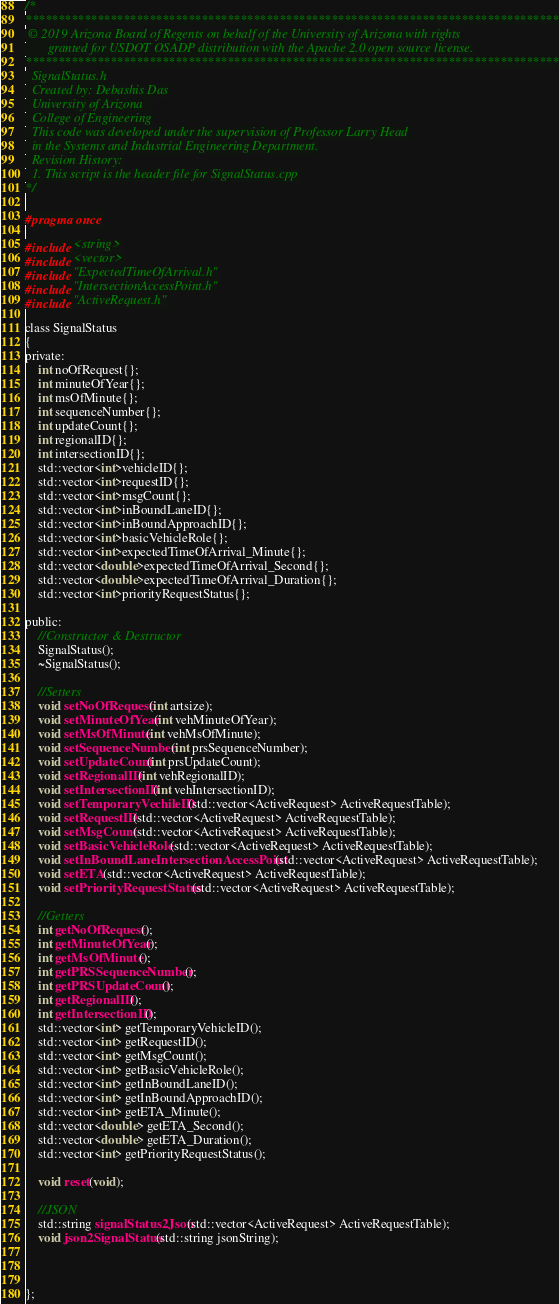Convert code to text. <code><loc_0><loc_0><loc_500><loc_500><_C_>/*
**********************************************************************************
 © 2019 Arizona Board of Regents on behalf of the University of Arizona with rights
       granted for USDOT OSADP distribution with the Apache 2.0 open source license.
**********************************************************************************
  SignalStatus.h
  Created by: Debashis Das
  University of Arizona   
  College of Engineering
  This code was developed under the supervision of Professor Larry Head
  in the Systems and Industrial Engineering Department.
  Revision History:
  1. This script is the header file for SignalStatus.cpp
*/

#pragma once

#include <string>
#include <vector>
#include "ExpectedTimeOfArrival.h"
#include "IntersectionAccessPoint.h"
#include "ActiveRequest.h"

class SignalStatus
{
private:
	int noOfRequest{};
	int minuteOfYear{};
	int msOfMinute{};
	int sequenceNumber{};
	int updateCount{};
	int regionalID{};
	int intersectionID{};
	std::vector<int>vehicleID{};
	std::vector<int>requestID{};
	std::vector<int>msgCount{};
	std::vector<int>inBoundLaneID{};
	std::vector<int>inBoundApproachID{};
	std::vector<int>basicVehicleRole{};
	std::vector<int>expectedTimeOfArrival_Minute{};
	std::vector<double>expectedTimeOfArrival_Second{};
	std::vector<double>expectedTimeOfArrival_Duration{};
	std::vector<int>priorityRequestStatus{};

public:
	//Constructor & Destructor
	SignalStatus();
	~SignalStatus();

	//Setters
	void setNoOfRequest(int artsize);
	void setMinuteOfYear(int vehMinuteOfYear);
	void setMsOfMinute(int vehMsOfMinute);
	void setSequenceNumber(int prsSequenceNumber);
	void setUpdateCount(int prsUpdateCount);
	void setRegionalID(int vehRegionalID);
	void setIntersectionID(int vehIntersectionID);
	void setTemporaryVechileID(std::vector<ActiveRequest> ActiveRequestTable);
	void setRequestID(std::vector<ActiveRequest> ActiveRequestTable);
	void setMsgCount(std::vector<ActiveRequest> ActiveRequestTable);
	void setBasicVehicleRole(std::vector<ActiveRequest> ActiveRequestTable);
	void setInBoundLaneIntersectionAccessPoint(std::vector<ActiveRequest> ActiveRequestTable);
	void setETA(std::vector<ActiveRequest> ActiveRequestTable);
	void setPriorityRequestStatus(std::vector<ActiveRequest> ActiveRequestTable);

	//Getters
	int getNoOfRequest();
	int getMinuteOfYear();
	int getMsOfMinute();
	int getPRSSequenceNumber();
	int getPRSUpdateCount();
	int getRegionalID();
	int getIntersectionID();
	std::vector<int> getTemporaryVehicleID();
	std::vector<int> getRequestID();
	std::vector<int> getMsgCount();
	std::vector<int> getBasicVehicleRole();
	std::vector<int> getInBoundLaneID();
	std::vector<int> getInBoundApproachID();
	std::vector<int> getETA_Minute();
	std::vector<double> getETA_Second();
	std::vector<double> getETA_Duration();
	std::vector<int> getPriorityRequestStatus();

	void reset(void);

	//JSON
	std::string signalStatus2Json(std::vector<ActiveRequest> ActiveRequestTable);
	void json2SignalStatus(std::string jsonString);



};</code> 